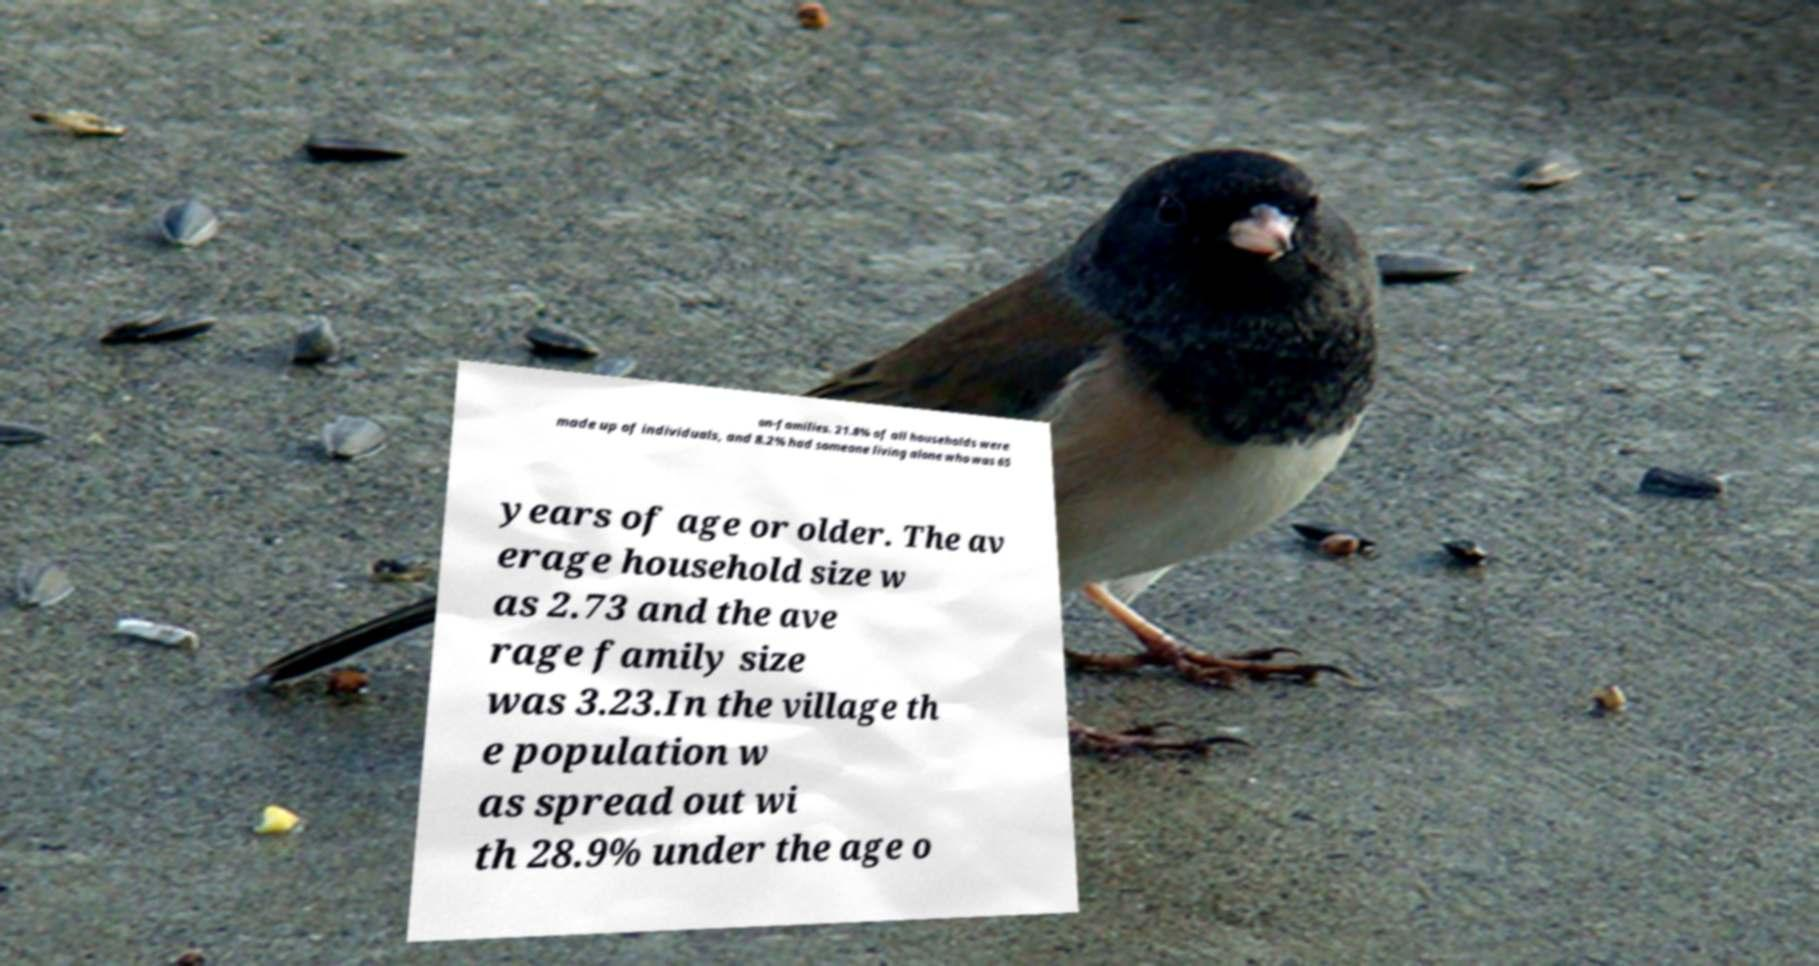I need the written content from this picture converted into text. Can you do that? on-families. 21.8% of all households were made up of individuals, and 8.2% had someone living alone who was 65 years of age or older. The av erage household size w as 2.73 and the ave rage family size was 3.23.In the village th e population w as spread out wi th 28.9% under the age o 